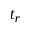<formula> <loc_0><loc_0><loc_500><loc_500>t _ { r }</formula> 